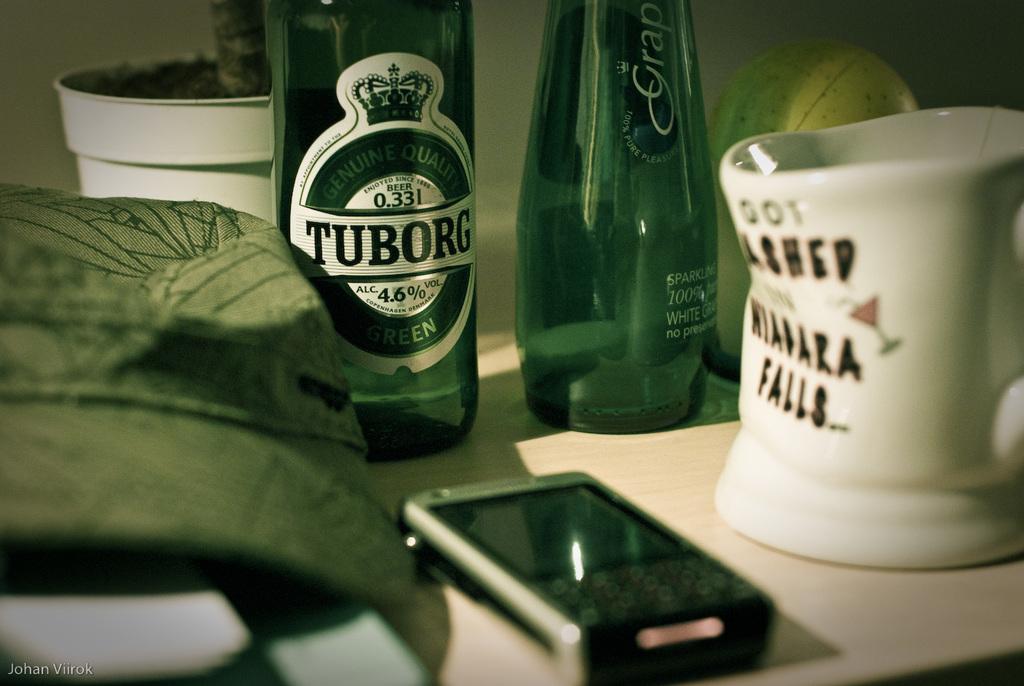What brand name is on the bottle on the left?
Your answer should be very brief. Tuborg. 